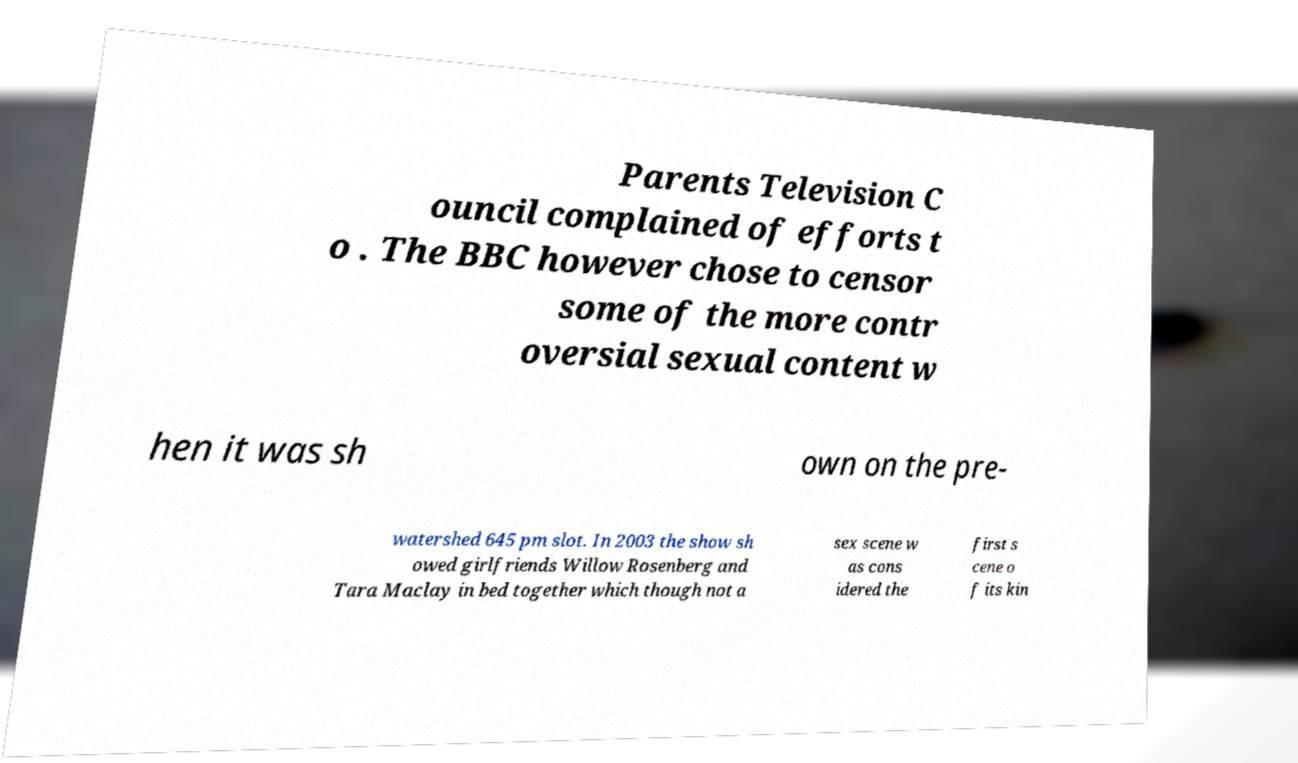What messages or text are displayed in this image? I need them in a readable, typed format. Parents Television C ouncil complained of efforts t o . The BBC however chose to censor some of the more contr oversial sexual content w hen it was sh own on the pre- watershed 645 pm slot. In 2003 the show sh owed girlfriends Willow Rosenberg and Tara Maclay in bed together which though not a sex scene w as cons idered the first s cene o f its kin 